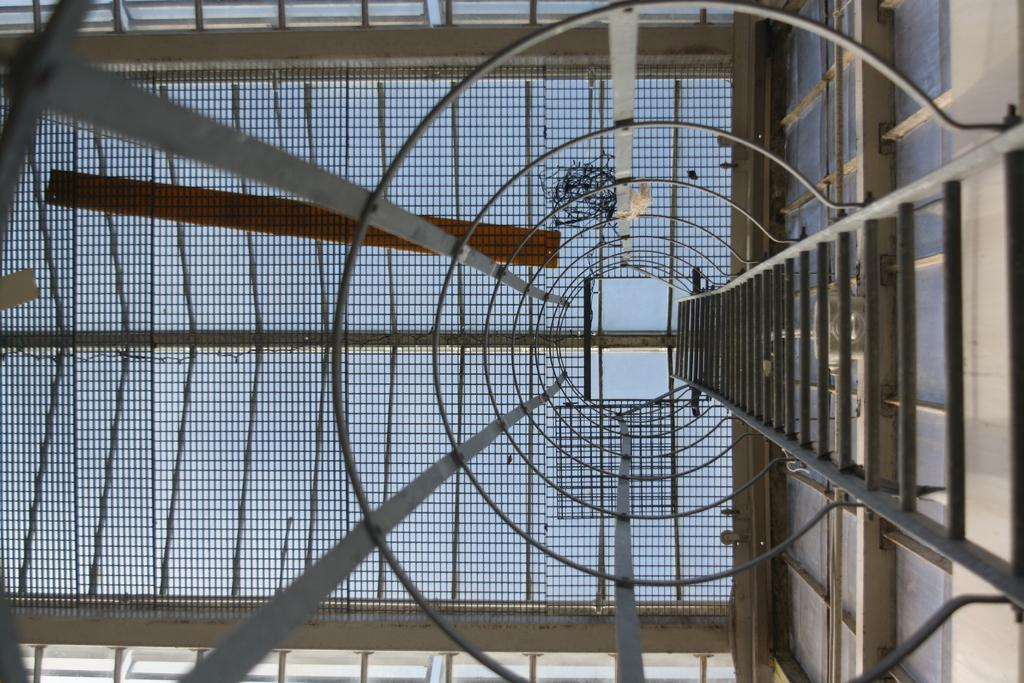What type of structure is visible in the image? There is a fence with rods in the image. What is another object that can be seen in the image? There is a ladder in the image. What is located on the right side of the image? There is a wall on the right side of the image. What type of teeth can be seen on the ladder in the image? There are no teeth present on the ladder or any other object in the image. Can you tell me how much the cushion costs in the image? There is no cushion or any reference to cost in the image. 